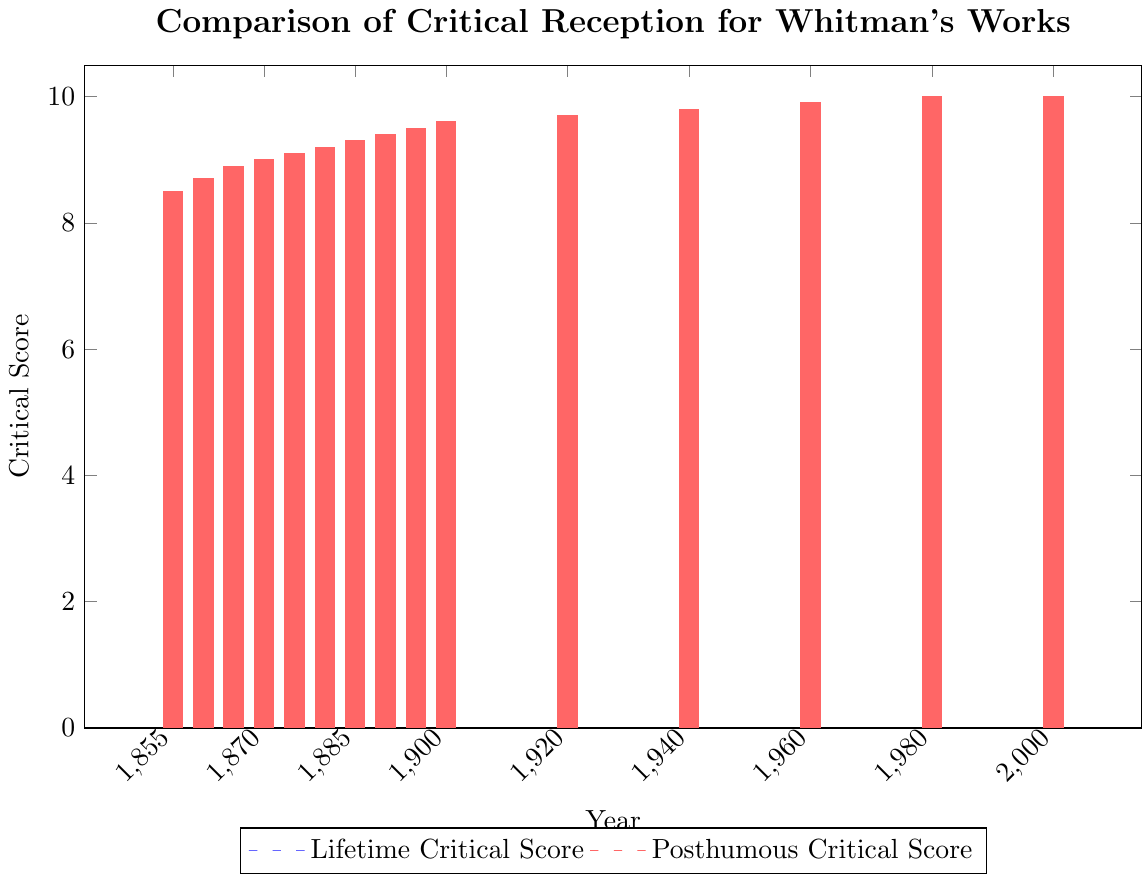What's the difference in the critical reception score for Whitman's works in 1890 between his lifetime and posthumously? In 1890, the lifetime critical score is 7.0 and the posthumous critical score is 9.4. The difference is calculated by subtracting the lifetime score from the posthumous score: 9.4 - 7.0.
Answer: 2.4 How does the posthumous critical reception score change from 1855 to 2000? Using the posthumous scores from 1855 (8.5) to 2000 (10.0), subtract 8.5 from 10.0 to find the change: 10.0 - 8.5.
Answer: 1.5 In which decade did Whitman's works see the largest increase in critical reception during his lifetime? Examine the bars representing lifetime critical scores for each decade. The largest increase is between 1865 and 1870 (from 4.5 to 5.2), which is an increase of 0.7.
Answer: 1860s to 1870s By how much did the lifetime critical score rise from 1855 to 1895? The score in 1855 is 3.2, and in 1895 it is 7.2. The difference is calculated by subtracting 3.2 from 7.2: 7.2 - 3.2.
Answer: 4.0 What is the trend of posthumous critical scores over the decades shown in the figure? The posthumous critical scores increase steadily from 8.5 in 1855 to 10.0 in 1980 and 2000, indicating a consistent rise in critical reception over time.
Answer: Consistent increase What year did the lifetime critical score first exceed 6.0? By inspecting the bars, the lifetime critical score first exceeds 6.0 in 1880 where the score is 6.3.
Answer: 1880 Which score is higher in 1885: lifetime or posthumous? Compare the bars for 1885: the lifetime score is 6.7 and the posthumous score is 9.3.
Answer: Posthumous How many times did the lifetime critical score increase in the years shown? From the values in the lifetime column, the score increases consistently without decreasing, moving from 3.2 in 1855 to 7.2 in 1895.
Answer: 8 times Is there any year in which the posthumous critical score decreased compared to the previous period? Examine the posthumous critical scores from 1855 to 2000. The scores consistently increase without any decrease.
Answer: No What is the average lifetime critical reception score from 1855 to 1895? Sum the lifetime scores: 3.2 + 3.8 + 4.5 + 5.2 + 5.8 + 6.3 + 6.7 + 7.0 + 7.2 = 43.7. Divide by the number of years (9): 43.7 / 9.
Answer: 4.85 